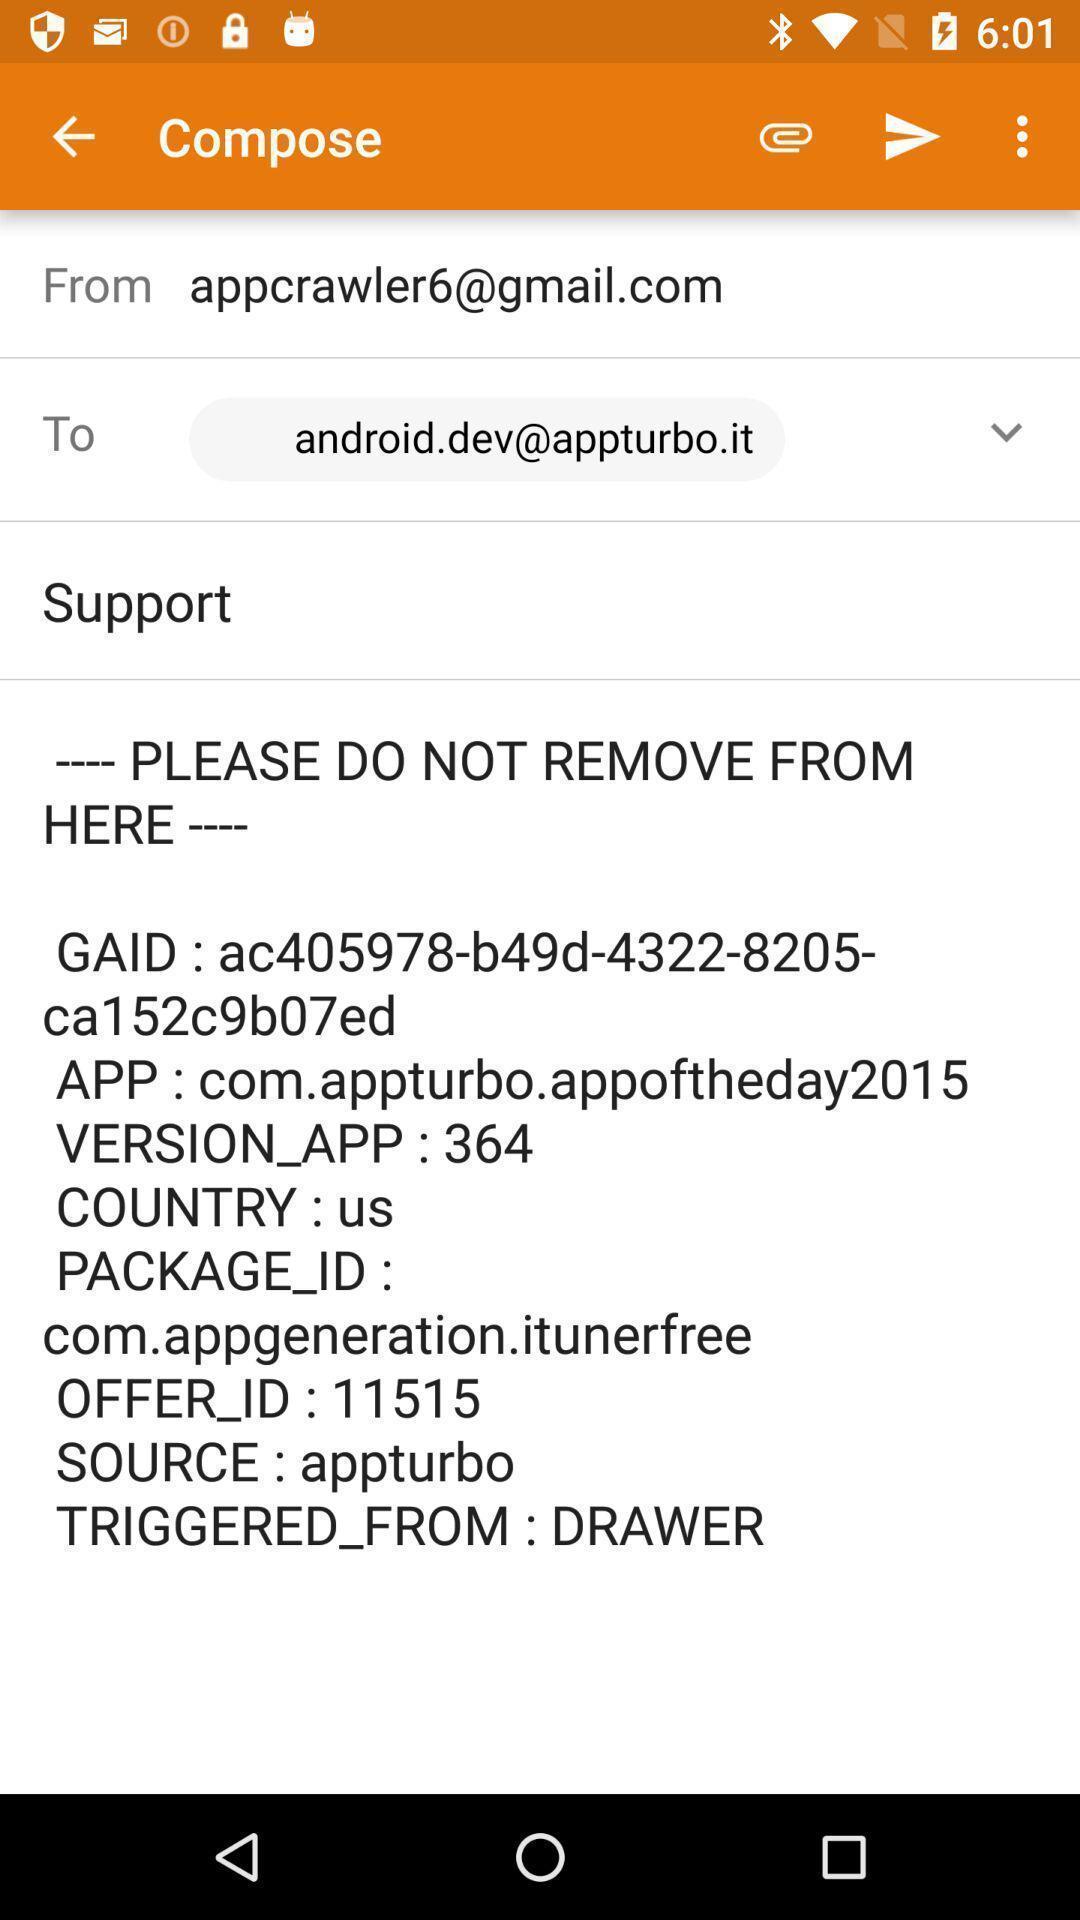Give me a summary of this screen capture. Screen show to compose a mail. 